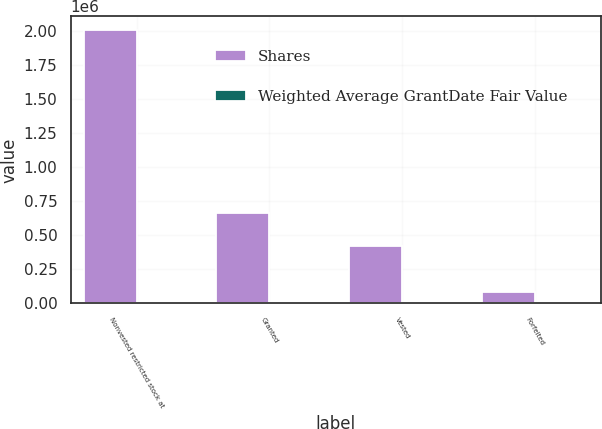Convert chart to OTSL. <chart><loc_0><loc_0><loc_500><loc_500><stacked_bar_chart><ecel><fcel>Nonvested restricted stock at<fcel>Granted<fcel>Vested<fcel>Forfeited<nl><fcel>Shares<fcel>2.0073e+06<fcel>666571<fcel>421261<fcel>82987<nl><fcel>Weighted Average GrantDate Fair Value<fcel>62.12<fcel>68.1<fcel>34.1<fcel>63.22<nl></chart> 